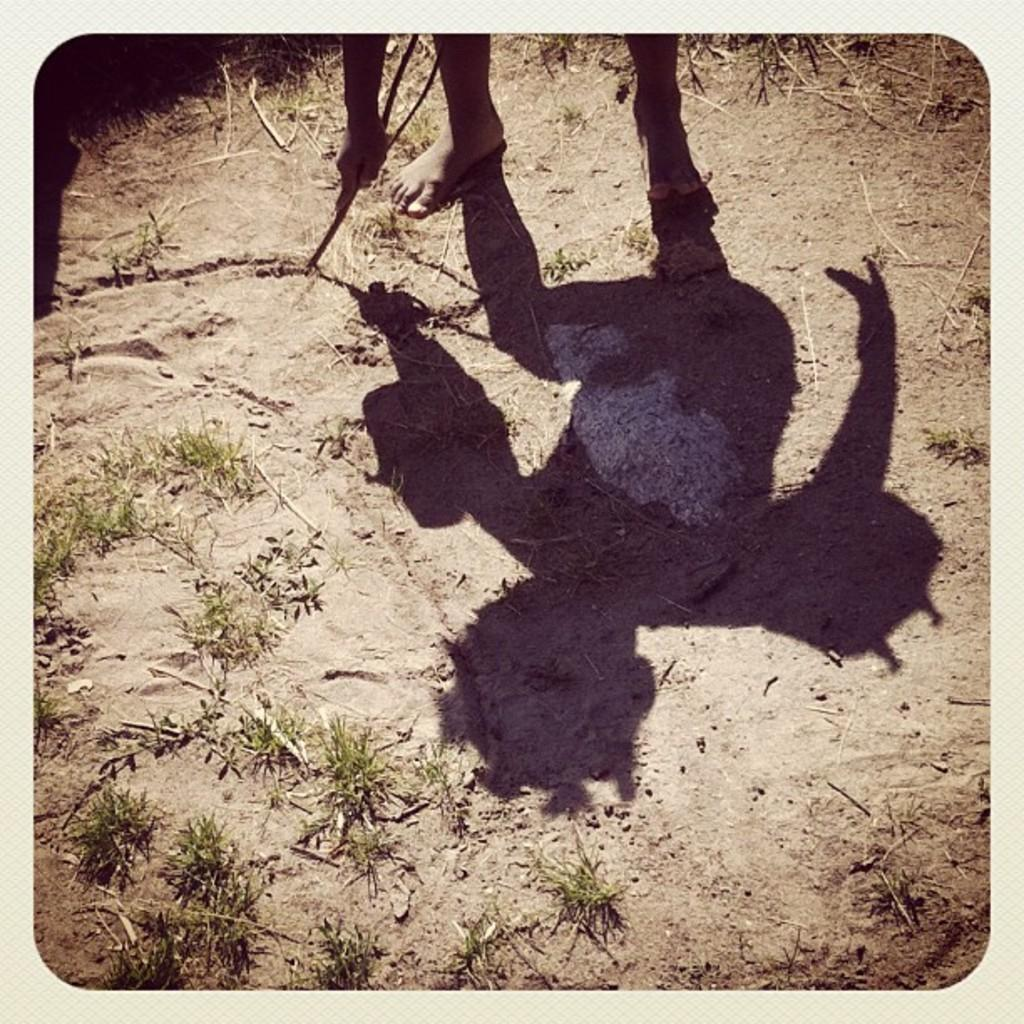What is the main subject of the image? There is a person in the image. What is the person holding in the image? The person is holding a stick. What type of vegetation can be seen in the image? There are plants visible in the image. What can be observed about the person's shadow in the image? The person's shadow is present on the ground. How many cats are playing with the bone in the image? There are no cats or bones present in the image. What type of thrill can be experienced by the person in the image? The image does not convey any specific emotions or experiences, so it is not possible to determine the type of thrill the person might be experiencing. 